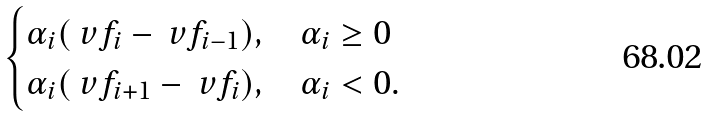<formula> <loc_0><loc_0><loc_500><loc_500>\begin{cases} \alpha _ { i } ( \ v f _ { i } - \ v f _ { i - 1 } ) , & \alpha _ { i } \geq 0 \\ \alpha _ { i } ( \ v f _ { i + 1 } - \ v f _ { i } ) , & \alpha _ { i } < 0 . \end{cases}</formula> 